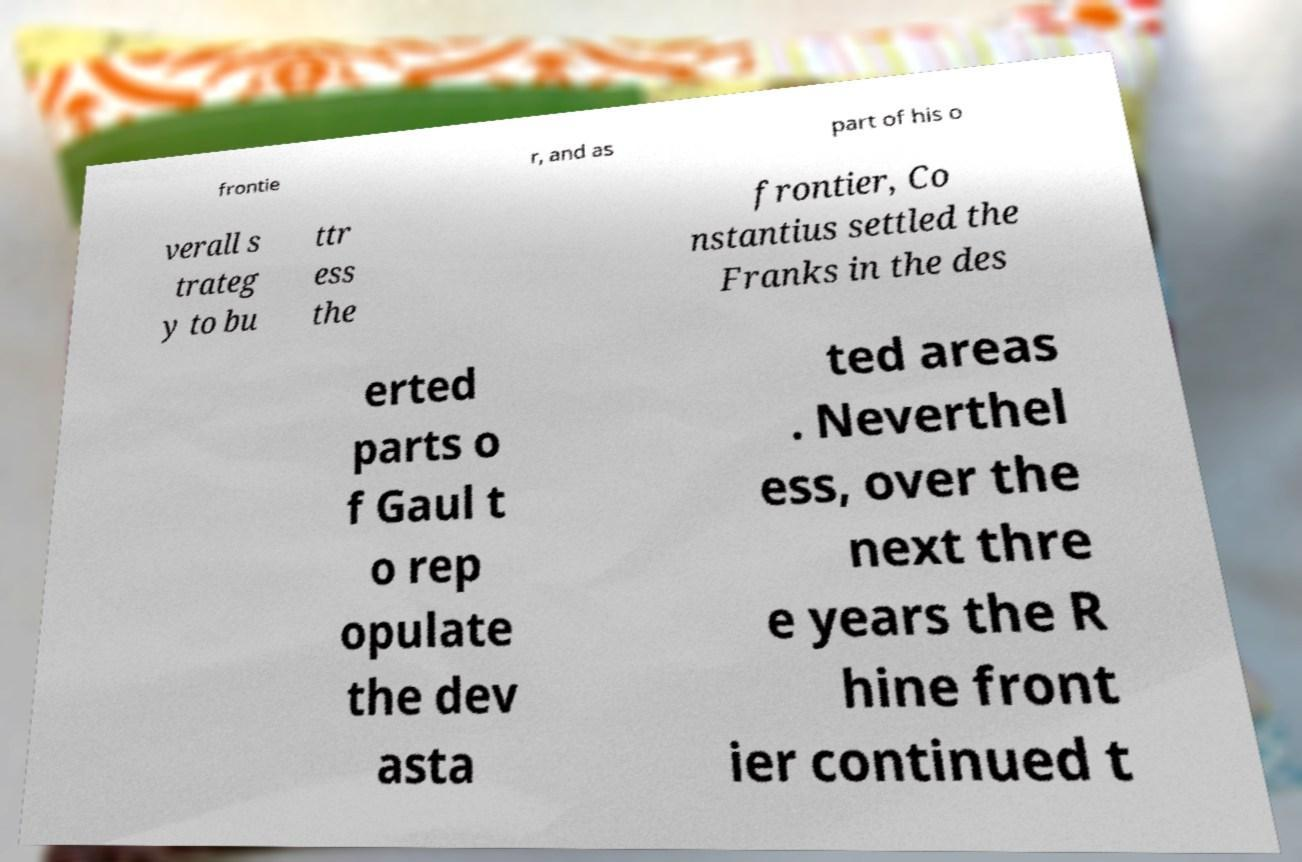Could you assist in decoding the text presented in this image and type it out clearly? frontie r, and as part of his o verall s trateg y to bu ttr ess the frontier, Co nstantius settled the Franks in the des erted parts o f Gaul t o rep opulate the dev asta ted areas . Neverthel ess, over the next thre e years the R hine front ier continued t 